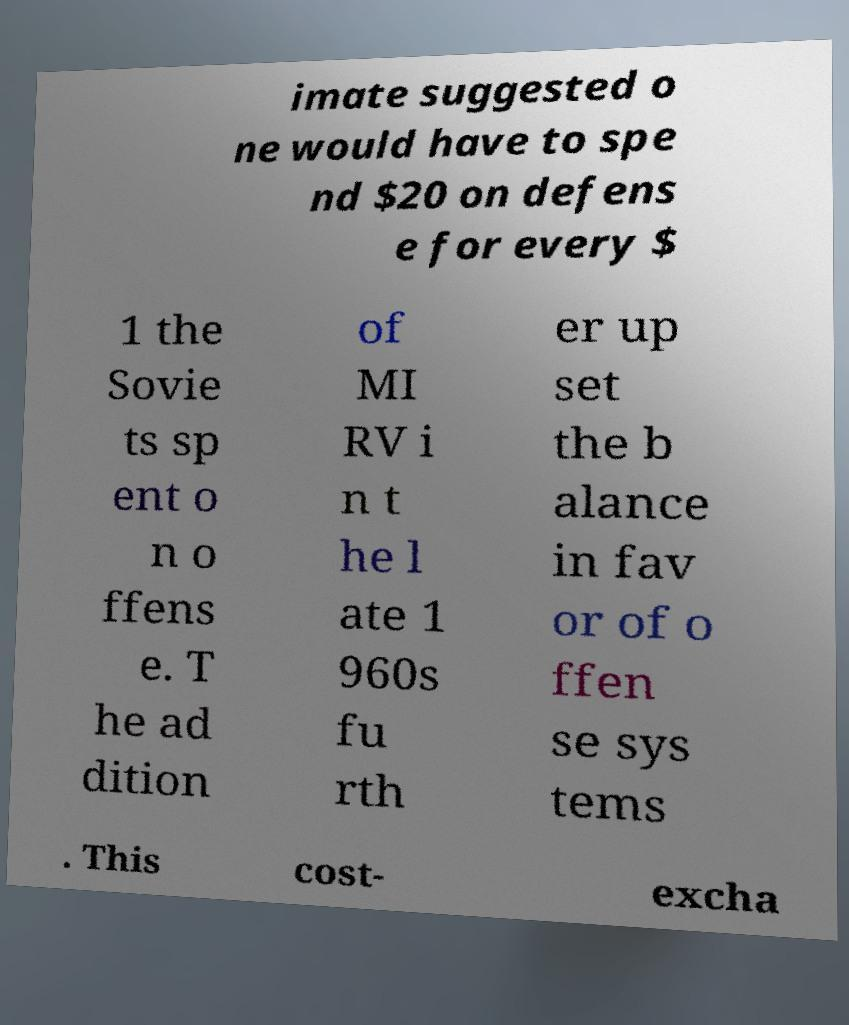Please read and relay the text visible in this image. What does it say? imate suggested o ne would have to spe nd $20 on defens e for every $ 1 the Sovie ts sp ent o n o ffens e. T he ad dition of MI RV i n t he l ate 1 960s fu rth er up set the b alance in fav or of o ffen se sys tems . This cost- excha 